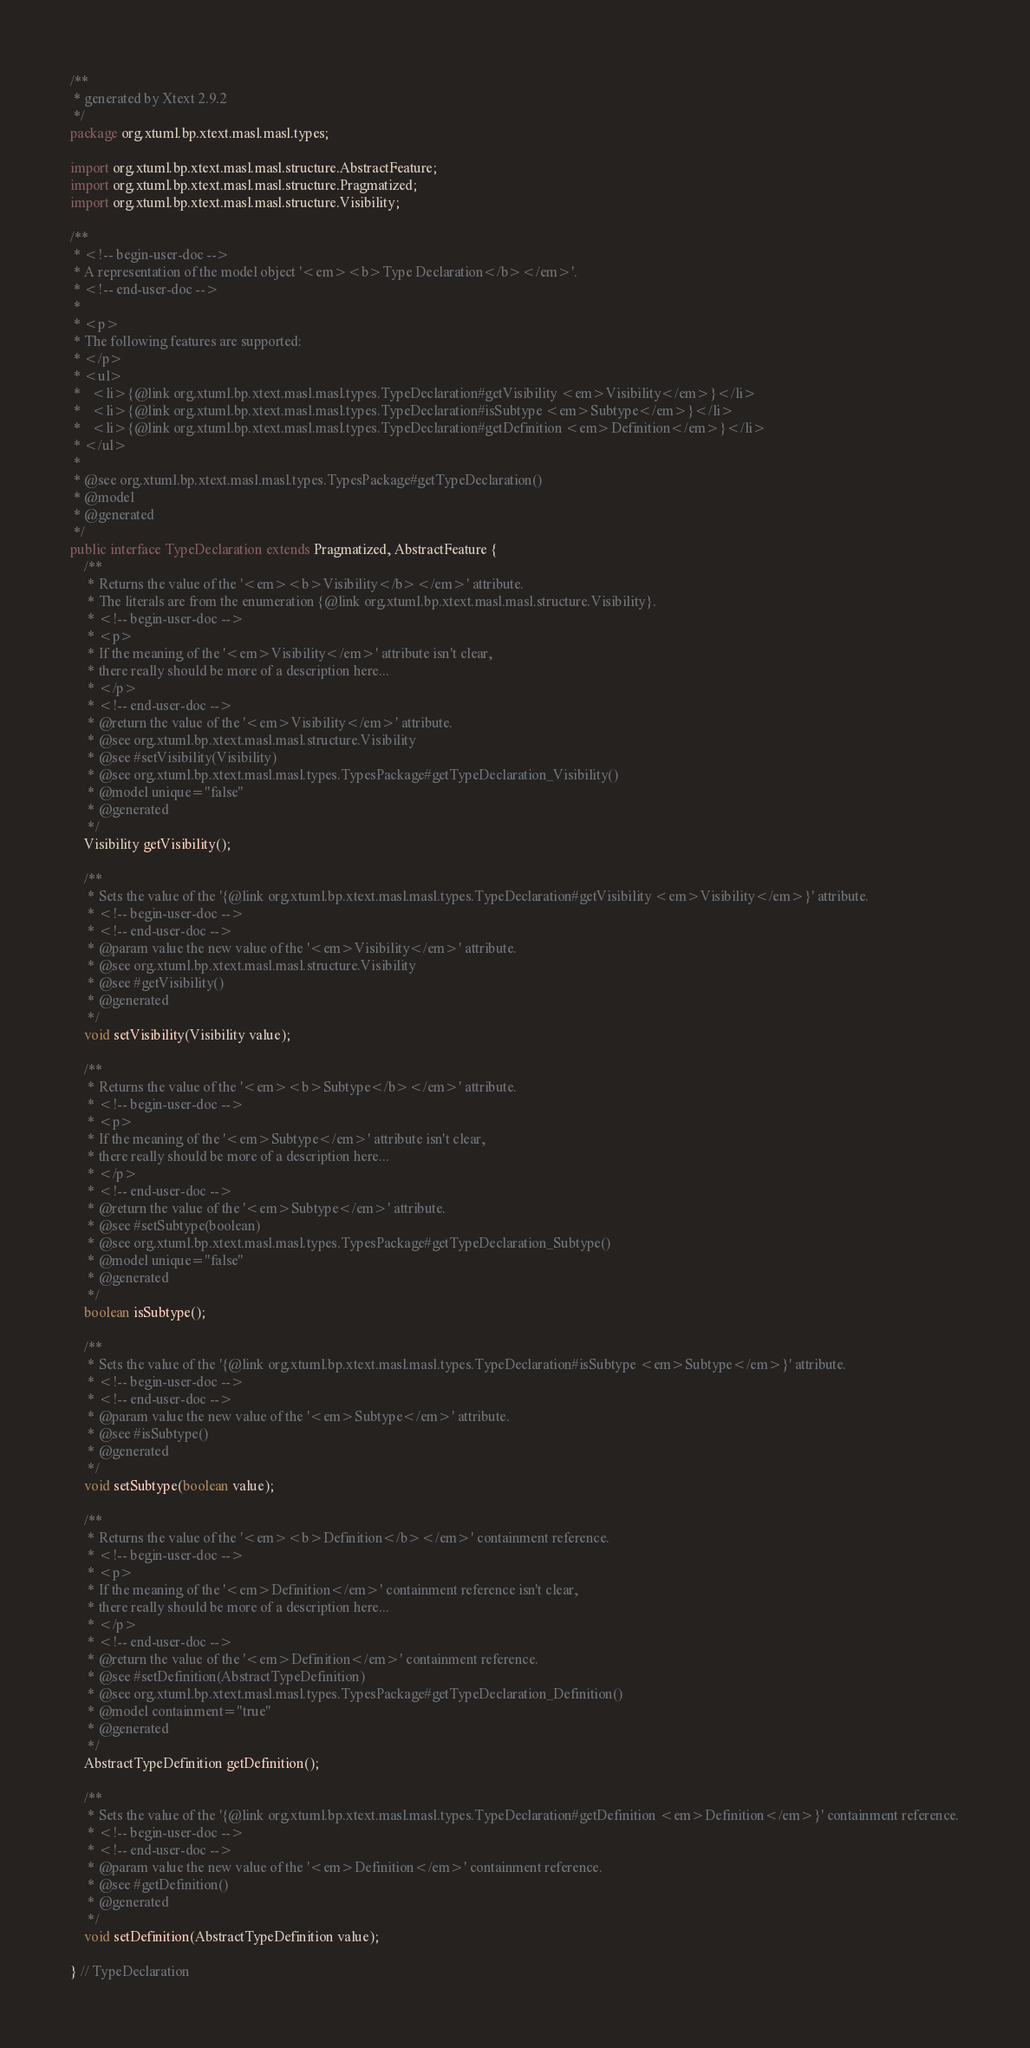<code> <loc_0><loc_0><loc_500><loc_500><_Java_>/**
 * generated by Xtext 2.9.2
 */
package org.xtuml.bp.xtext.masl.masl.types;

import org.xtuml.bp.xtext.masl.masl.structure.AbstractFeature;
import org.xtuml.bp.xtext.masl.masl.structure.Pragmatized;
import org.xtuml.bp.xtext.masl.masl.structure.Visibility;

/**
 * <!-- begin-user-doc -->
 * A representation of the model object '<em><b>Type Declaration</b></em>'.
 * <!-- end-user-doc -->
 *
 * <p>
 * The following features are supported:
 * </p>
 * <ul>
 *   <li>{@link org.xtuml.bp.xtext.masl.masl.types.TypeDeclaration#getVisibility <em>Visibility</em>}</li>
 *   <li>{@link org.xtuml.bp.xtext.masl.masl.types.TypeDeclaration#isSubtype <em>Subtype</em>}</li>
 *   <li>{@link org.xtuml.bp.xtext.masl.masl.types.TypeDeclaration#getDefinition <em>Definition</em>}</li>
 * </ul>
 *
 * @see org.xtuml.bp.xtext.masl.masl.types.TypesPackage#getTypeDeclaration()
 * @model
 * @generated
 */
public interface TypeDeclaration extends Pragmatized, AbstractFeature {
	/**
	 * Returns the value of the '<em><b>Visibility</b></em>' attribute.
	 * The literals are from the enumeration {@link org.xtuml.bp.xtext.masl.masl.structure.Visibility}.
	 * <!-- begin-user-doc -->
	 * <p>
	 * If the meaning of the '<em>Visibility</em>' attribute isn't clear,
	 * there really should be more of a description here...
	 * </p>
	 * <!-- end-user-doc -->
	 * @return the value of the '<em>Visibility</em>' attribute.
	 * @see org.xtuml.bp.xtext.masl.masl.structure.Visibility
	 * @see #setVisibility(Visibility)
	 * @see org.xtuml.bp.xtext.masl.masl.types.TypesPackage#getTypeDeclaration_Visibility()
	 * @model unique="false"
	 * @generated
	 */
	Visibility getVisibility();

	/**
	 * Sets the value of the '{@link org.xtuml.bp.xtext.masl.masl.types.TypeDeclaration#getVisibility <em>Visibility</em>}' attribute.
	 * <!-- begin-user-doc -->
	 * <!-- end-user-doc -->
	 * @param value the new value of the '<em>Visibility</em>' attribute.
	 * @see org.xtuml.bp.xtext.masl.masl.structure.Visibility
	 * @see #getVisibility()
	 * @generated
	 */
	void setVisibility(Visibility value);

	/**
	 * Returns the value of the '<em><b>Subtype</b></em>' attribute.
	 * <!-- begin-user-doc -->
	 * <p>
	 * If the meaning of the '<em>Subtype</em>' attribute isn't clear,
	 * there really should be more of a description here...
	 * </p>
	 * <!-- end-user-doc -->
	 * @return the value of the '<em>Subtype</em>' attribute.
	 * @see #setSubtype(boolean)
	 * @see org.xtuml.bp.xtext.masl.masl.types.TypesPackage#getTypeDeclaration_Subtype()
	 * @model unique="false"
	 * @generated
	 */
	boolean isSubtype();

	/**
	 * Sets the value of the '{@link org.xtuml.bp.xtext.masl.masl.types.TypeDeclaration#isSubtype <em>Subtype</em>}' attribute.
	 * <!-- begin-user-doc -->
	 * <!-- end-user-doc -->
	 * @param value the new value of the '<em>Subtype</em>' attribute.
	 * @see #isSubtype()
	 * @generated
	 */
	void setSubtype(boolean value);

	/**
	 * Returns the value of the '<em><b>Definition</b></em>' containment reference.
	 * <!-- begin-user-doc -->
	 * <p>
	 * If the meaning of the '<em>Definition</em>' containment reference isn't clear,
	 * there really should be more of a description here...
	 * </p>
	 * <!-- end-user-doc -->
	 * @return the value of the '<em>Definition</em>' containment reference.
	 * @see #setDefinition(AbstractTypeDefinition)
	 * @see org.xtuml.bp.xtext.masl.masl.types.TypesPackage#getTypeDeclaration_Definition()
	 * @model containment="true"
	 * @generated
	 */
	AbstractTypeDefinition getDefinition();

	/**
	 * Sets the value of the '{@link org.xtuml.bp.xtext.masl.masl.types.TypeDeclaration#getDefinition <em>Definition</em>}' containment reference.
	 * <!-- begin-user-doc -->
	 * <!-- end-user-doc -->
	 * @param value the new value of the '<em>Definition</em>' containment reference.
	 * @see #getDefinition()
	 * @generated
	 */
	void setDefinition(AbstractTypeDefinition value);

} // TypeDeclaration
</code> 